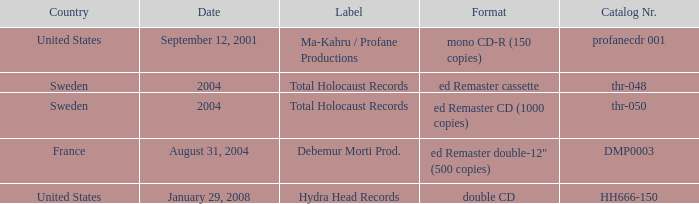Which date has Total Holocaust records in the ed Remaster cassette format? 2004.0. 